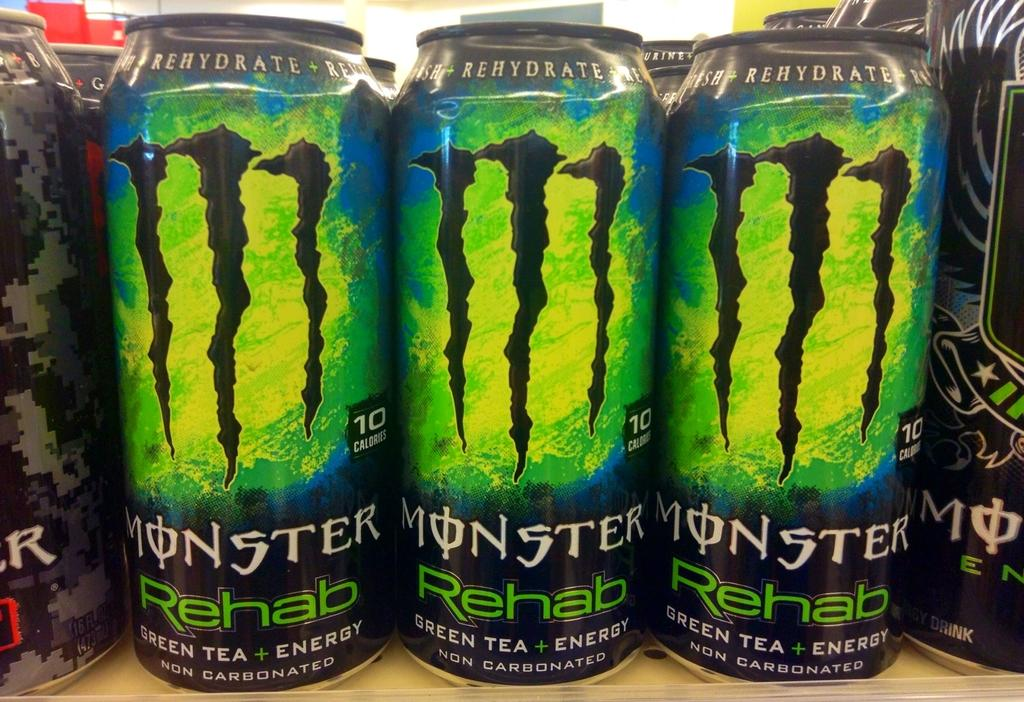What is the color of the surface on which the objects are placed in the image? The surface is brown in color. What can be found on the tins in the image? There is writing on the tins in the image. What type of attraction can be seen in the background of the image? There is no background or attraction visible in the image; it only shows objects on a brown surface and writing on tins. 